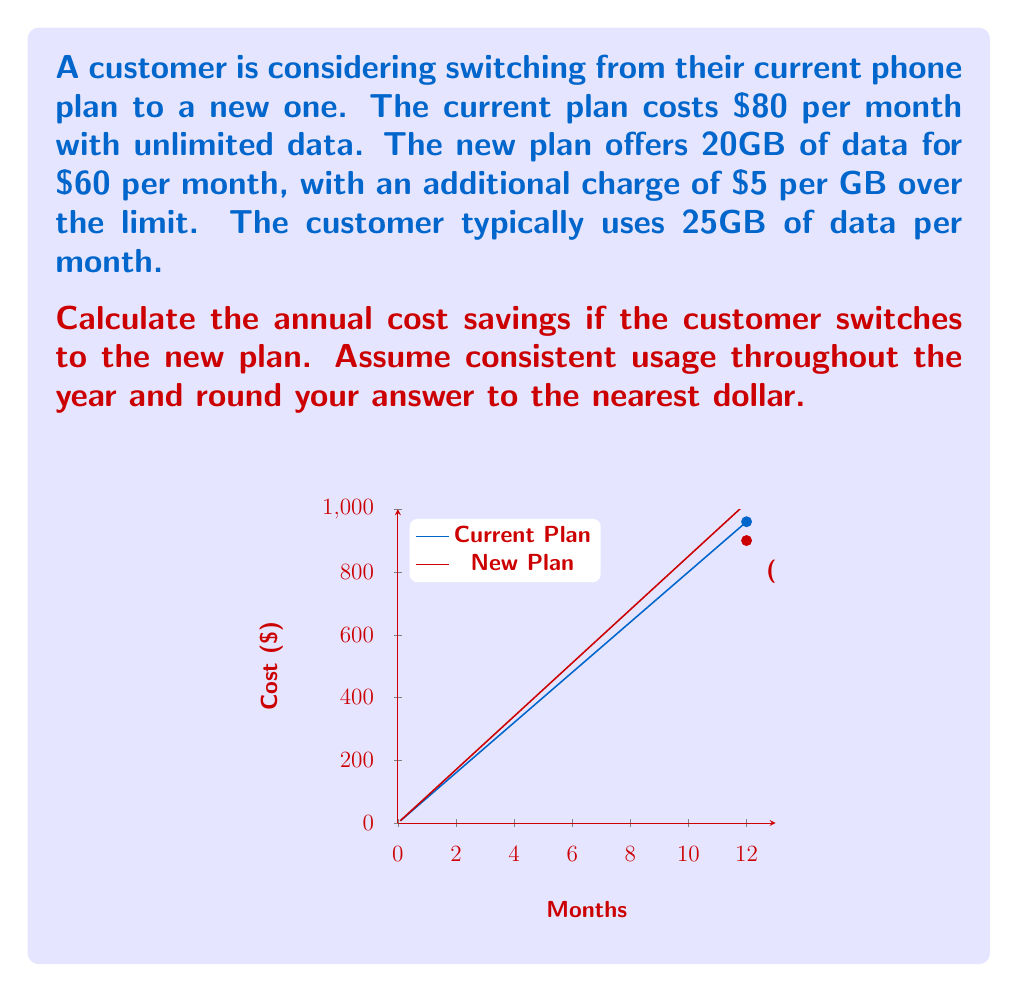Teach me how to tackle this problem. Let's approach this problem step-by-step:

1) First, calculate the monthly cost of the new plan:
   Base cost: $60
   Extra data: 25GB - 20GB = 5GB
   Extra cost: 5GB × $5/GB = $25
   Total monthly cost: $60 + $25 = $85

2) Now, let's calculate the annual costs:
   Current plan: $80 × 12 months = $960
   New plan: $85 × 12 months = $1020

3) To find the annual savings, subtract the new plan cost from the current plan cost:
   Annual savings = Current plan cost - New plan cost
   $$\text{Annual savings} = $960 - $1020 = -$60$$

4) The negative result indicates that the new plan would actually cost more annually.

5) To get the final answer, we take the absolute value of the savings (since the question asks for cost savings) and round to the nearest dollar:
   $$\text{Annual cost savings} = |-$60| = $60$$

Therefore, there are no cost savings. Instead, the new plan would cost $60 more per year.
Answer: $0 (The new plan costs $60 more annually) 